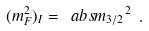Convert formula to latex. <formula><loc_0><loc_0><loc_500><loc_500>( m ^ { 2 } _ { F } ) _ { I } = \ a b s { m _ { 3 / 2 } } ^ { 2 } \ .</formula> 